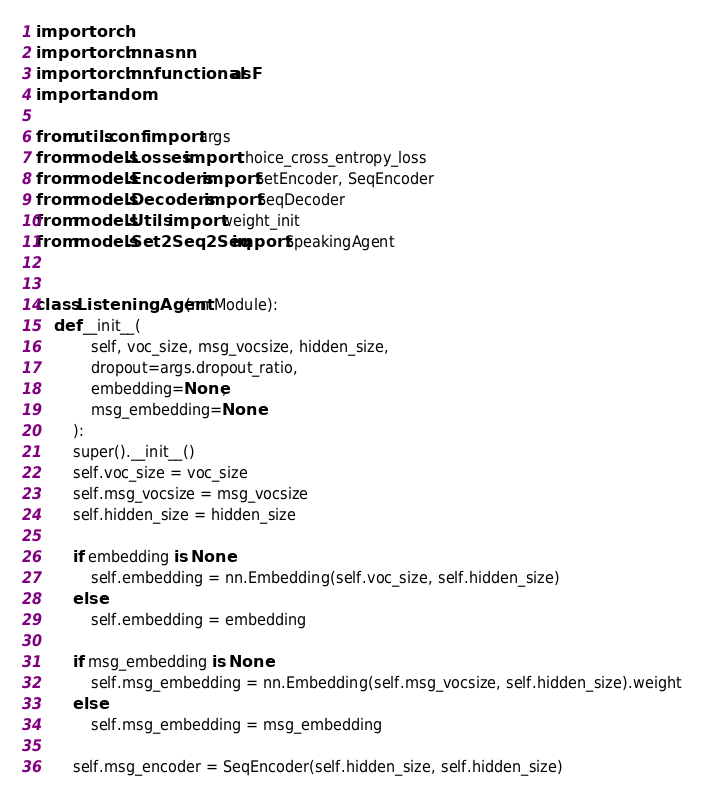<code> <loc_0><loc_0><loc_500><loc_500><_Python_>import torch
import torch.nn as nn
import torch.nn.functional as F
import random

from utils.conf import args
from models.Losses import choice_cross_entropy_loss
from models.Encoders import SetEncoder, SeqEncoder
from models.Decoders import SeqDecoder
from models.Utils import weight_init
from models.Set2Seq2Seq import SpeakingAgent


class ListeningAgent(nn.Module):
    def __init__(
            self, voc_size, msg_vocsize, hidden_size, 
            dropout=args.dropout_ratio,
            embedding=None,
            msg_embedding=None
        ):
        super().__init__()
        self.voc_size = voc_size
        self.msg_vocsize = msg_vocsize
        self.hidden_size = hidden_size

        if embedding is None:
            self.embedding = nn.Embedding(self.voc_size, self.hidden_size)
        else:
            self.embedding = embedding

        if msg_embedding is None:
            self.msg_embedding = nn.Embedding(self.msg_vocsize, self.hidden_size).weight
        else:
            self.msg_embedding = msg_embedding
        
        self.msg_encoder = SeqEncoder(self.hidden_size, self.hidden_size)</code> 